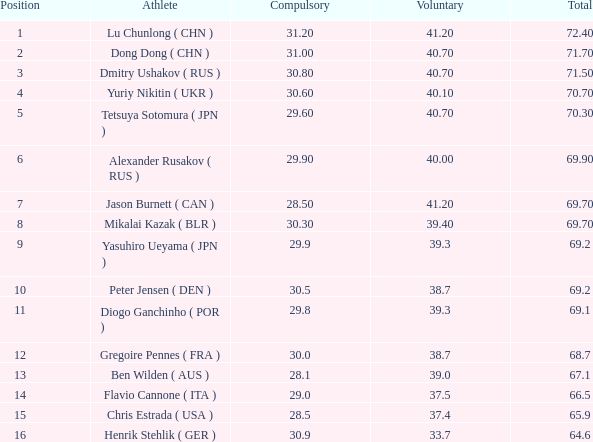What is the sum of the placement of the number 1? None. Parse the table in full. {'header': ['Position', 'Athlete', 'Compulsory', 'Voluntary', 'Total'], 'rows': [['1', 'Lu Chunlong ( CHN )', '31.20', '41.20', '72.40'], ['2', 'Dong Dong ( CHN )', '31.00', '40.70', '71.70'], ['3', 'Dmitry Ushakov ( RUS )', '30.80', '40.70', '71.50'], ['4', 'Yuriy Nikitin ( UKR )', '30.60', '40.10', '70.70'], ['5', 'Tetsuya Sotomura ( JPN )', '29.60', '40.70', '70.30'], ['6', 'Alexander Rusakov ( RUS )', '29.90', '40.00', '69.90'], ['7', 'Jason Burnett ( CAN )', '28.50', '41.20', '69.70'], ['8', 'Mikalai Kazak ( BLR )', '30.30', '39.40', '69.70'], ['9', 'Yasuhiro Ueyama ( JPN )', '29.9', '39.3', '69.2'], ['10', 'Peter Jensen ( DEN )', '30.5', '38.7', '69.2'], ['11', 'Diogo Ganchinho ( POR )', '29.8', '39.3', '69.1'], ['12', 'Gregoire Pennes ( FRA )', '30.0', '38.7', '68.7'], ['13', 'Ben Wilden ( AUS )', '28.1', '39.0', '67.1'], ['14', 'Flavio Cannone ( ITA )', '29.0', '37.5', '66.5'], ['15', 'Chris Estrada ( USA )', '28.5', '37.4', '65.9'], ['16', 'Henrik Stehlik ( GER )', '30.9', '33.7', '64.6']]} 